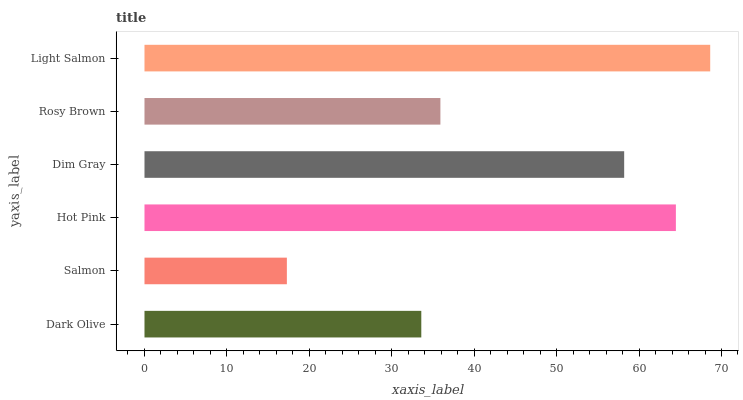Is Salmon the minimum?
Answer yes or no. Yes. Is Light Salmon the maximum?
Answer yes or no. Yes. Is Hot Pink the minimum?
Answer yes or no. No. Is Hot Pink the maximum?
Answer yes or no. No. Is Hot Pink greater than Salmon?
Answer yes or no. Yes. Is Salmon less than Hot Pink?
Answer yes or no. Yes. Is Salmon greater than Hot Pink?
Answer yes or no. No. Is Hot Pink less than Salmon?
Answer yes or no. No. Is Dim Gray the high median?
Answer yes or no. Yes. Is Rosy Brown the low median?
Answer yes or no. Yes. Is Rosy Brown the high median?
Answer yes or no. No. Is Dim Gray the low median?
Answer yes or no. No. 